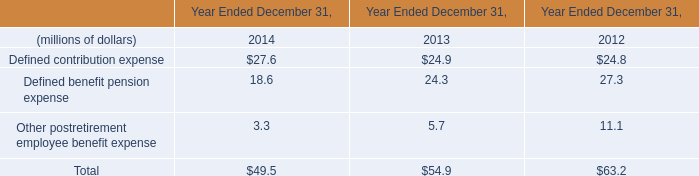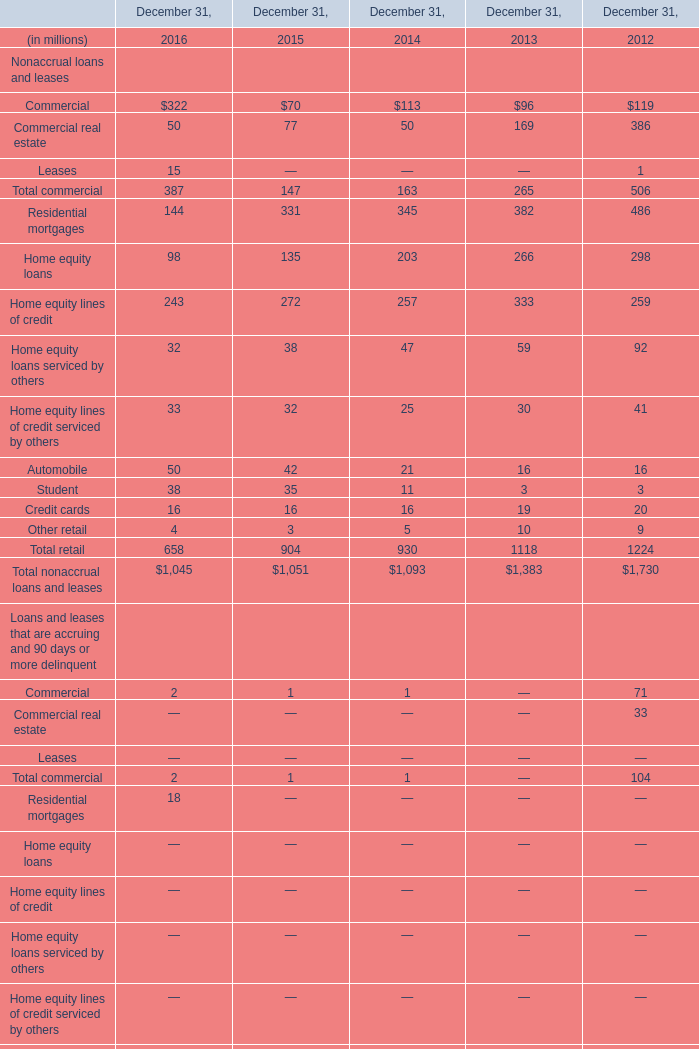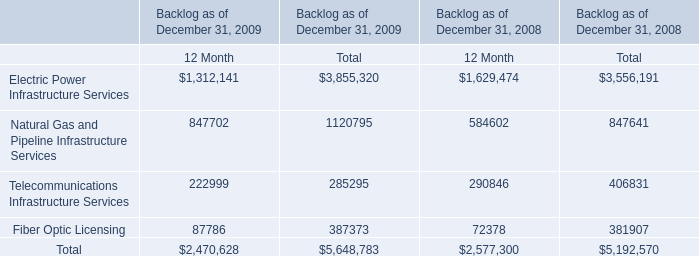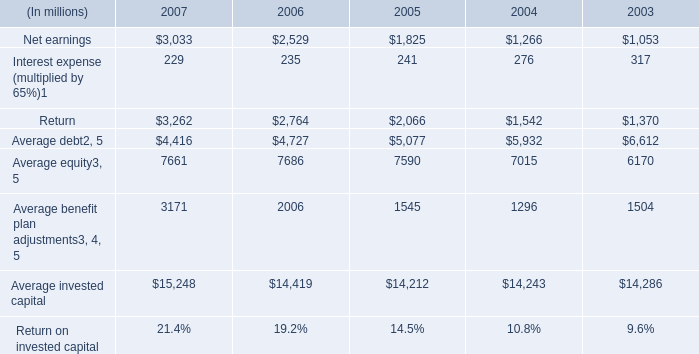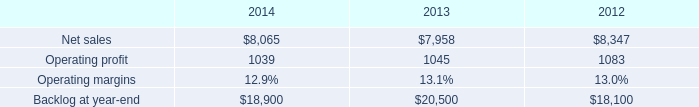what was the percent of the increase in the backlog from 2012 to 2013 
Computations: ((20500 - 18100) / 18100)
Answer: 0.1326. 